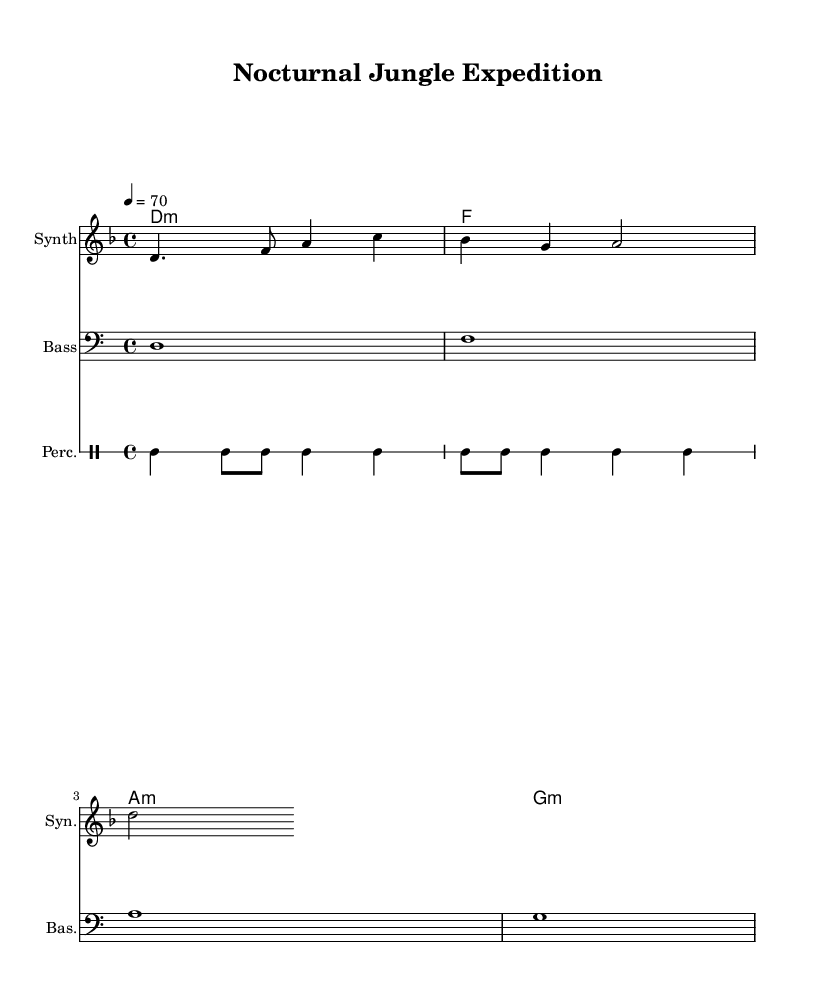What is the key signature of this music? The key signature indicates D minor, which has one flat (B flat). This can be observed at the beginning of the sheet music, where the key signature is specified.
Answer: D minor What is the time signature of this music? The time signature is 4/4, which means there are four beats in each measure. This is indicated at the start of the music, specifying the rhythmic structure.
Answer: 4/4 What is the tempo marking of this music? The tempo marking is 70 beats per minute, as shown at the beginning of the score. This informs the performer how fast to play the piece.
Answer: 70 What is the root chord of the first measure? The chord in the first measure is D minor, as indicated in the chord symbols and harmony section. The first note of the melody and the corresponding chord signify this.
Answer: D minor How many measures are present in the melody section? There are four measures in the melody section, which can be counted by looking at the vertical bar lines that separate each measure in the sheet music.
Answer: 4 What type of music is indicated for this score? The music is labeled as "Ambient electronic," based on its atmospheric qualities and the synthesized sound indicated by the instrumentation in the score.
Answer: Ambient electronic What instruments are specified in this music sheet? The sheet music specifies three instruments: a Synth, a Bass, and Percussion. This can be found in the instrumentation section of the score.
Answer: Synth, Bass, Percussion 